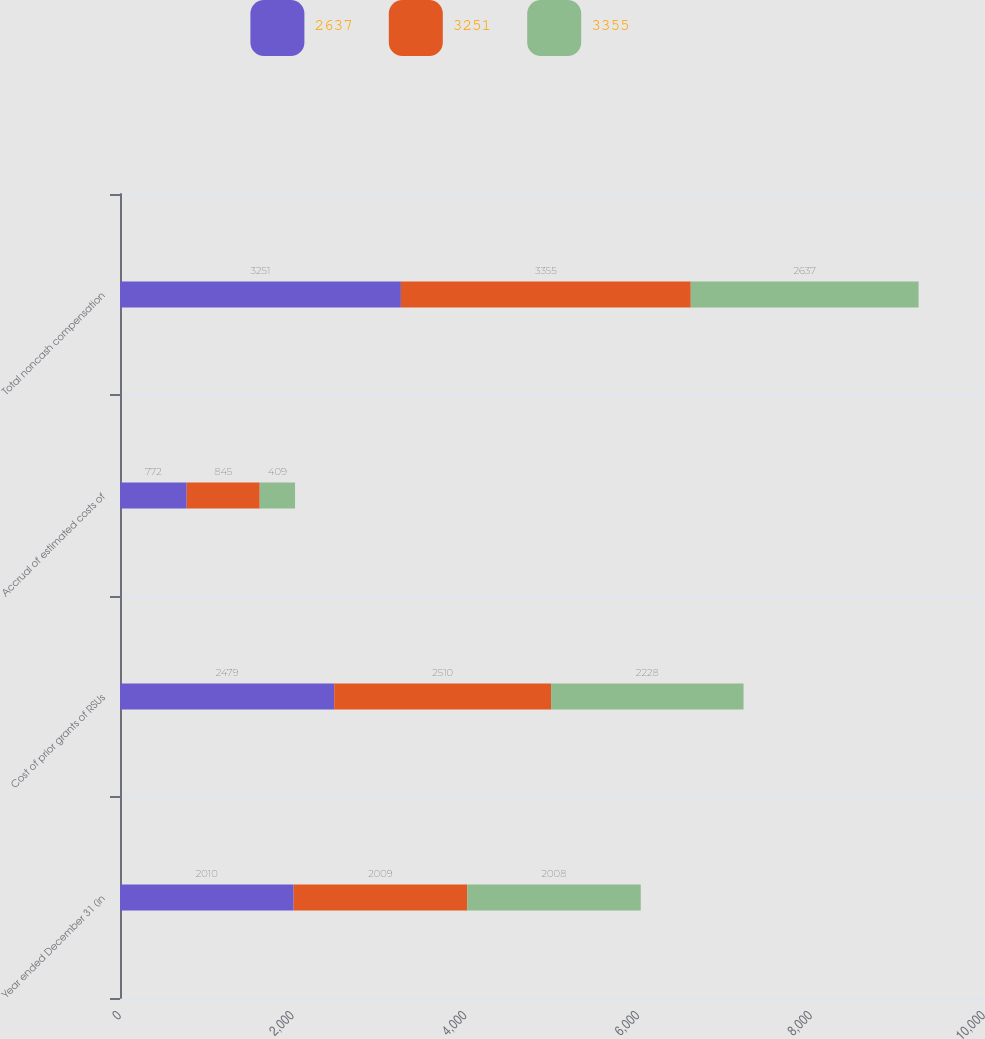Convert chart to OTSL. <chart><loc_0><loc_0><loc_500><loc_500><stacked_bar_chart><ecel><fcel>Year ended December 31 (in<fcel>Cost of prior grants of RSUs<fcel>Accrual of estimated costs of<fcel>Total noncash compensation<nl><fcel>2637<fcel>2010<fcel>2479<fcel>772<fcel>3251<nl><fcel>3251<fcel>2009<fcel>2510<fcel>845<fcel>3355<nl><fcel>3355<fcel>2008<fcel>2228<fcel>409<fcel>2637<nl></chart> 